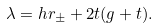Convert formula to latex. <formula><loc_0><loc_0><loc_500><loc_500>\lambda = h r _ { \pm } + 2 t ( g + t ) .</formula> 